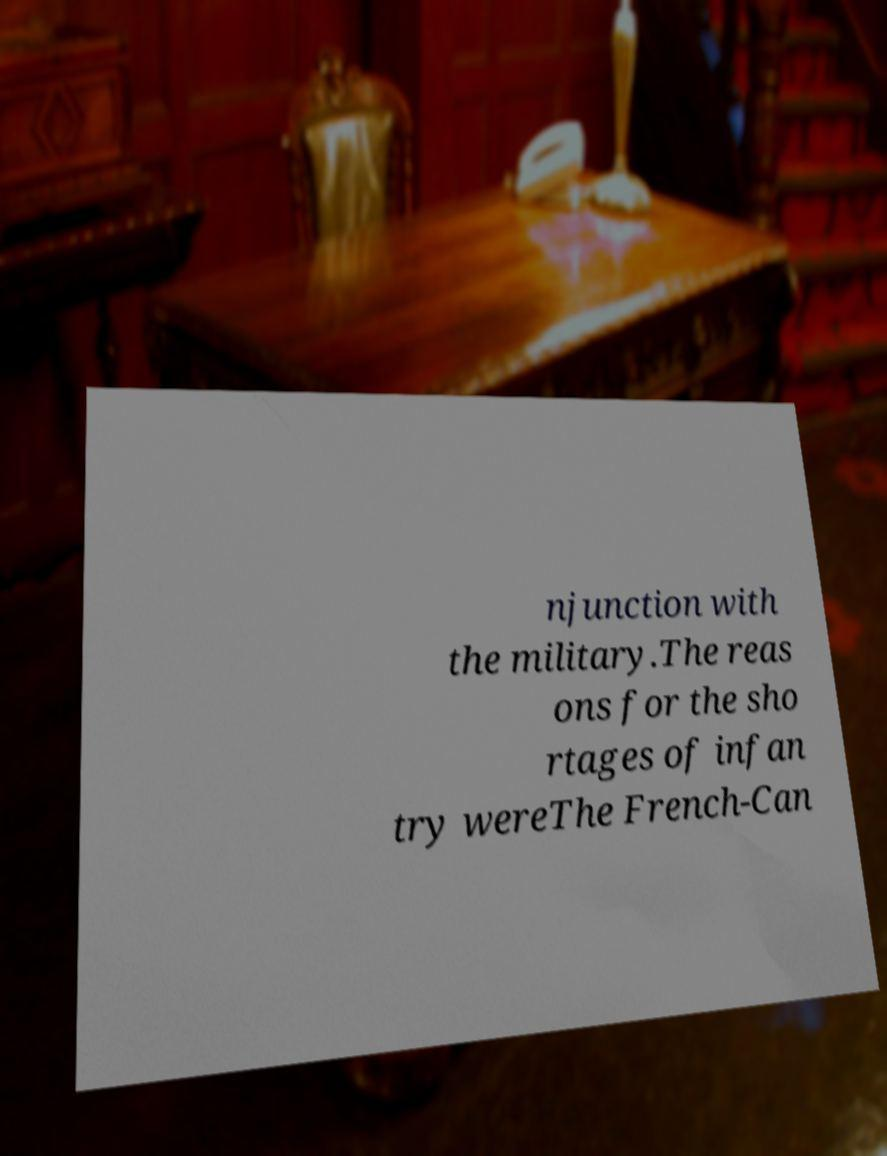Could you extract and type out the text from this image? njunction with the military.The reas ons for the sho rtages of infan try wereThe French-Can 